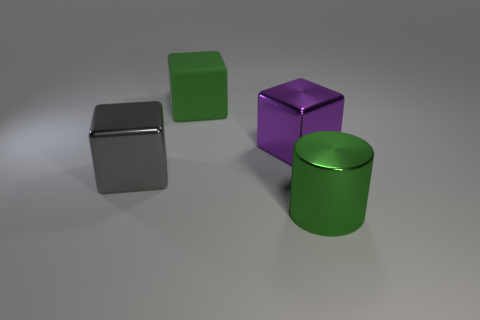Add 1 blue blocks. How many objects exist? 5 Subtract all blocks. How many objects are left? 1 Add 4 blocks. How many blocks are left? 7 Add 2 purple metal things. How many purple metal things exist? 3 Subtract 0 red balls. How many objects are left? 4 Subtract all green rubber blocks. Subtract all big cubes. How many objects are left? 0 